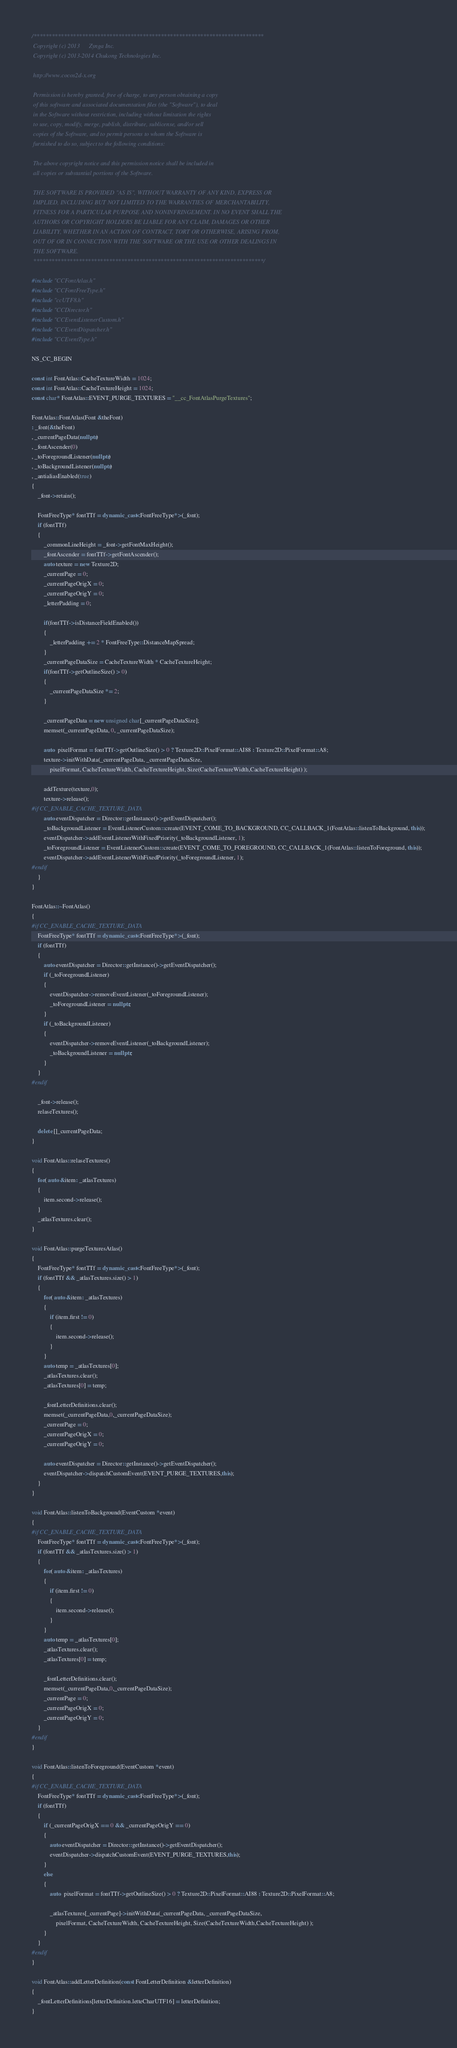Convert code to text. <code><loc_0><loc_0><loc_500><loc_500><_C++_>/****************************************************************************
 Copyright (c) 2013      Zynga Inc.
 Copyright (c) 2013-2014 Chukong Technologies Inc.
 
 http://www.cocos2d-x.org

 Permission is hereby granted, free of charge, to any person obtaining a copy
 of this software and associated documentation files (the "Software"), to deal
 in the Software without restriction, including without limitation the rights
 to use, copy, modify, merge, publish, distribute, sublicense, and/or sell
 copies of the Software, and to permit persons to whom the Software is
 furnished to do so, subject to the following conditions:

 The above copyright notice and this permission notice shall be included in
 all copies or substantial portions of the Software.

 THE SOFTWARE IS PROVIDED "AS IS", WITHOUT WARRANTY OF ANY KIND, EXPRESS OR
 IMPLIED, INCLUDING BUT NOT LIMITED TO THE WARRANTIES OF MERCHANTABILITY,
 FITNESS FOR A PARTICULAR PURPOSE AND NONINFRINGEMENT. IN NO EVENT SHALL THE
 AUTHORS OR COPYRIGHT HOLDERS BE LIABLE FOR ANY CLAIM, DAMAGES OR OTHER
 LIABILITY, WHETHER IN AN ACTION OF CONTRACT, TORT OR OTHERWISE, ARISING FROM,
 OUT OF OR IN CONNECTION WITH THE SOFTWARE OR THE USE OR OTHER DEALINGS IN
 THE SOFTWARE.
 ****************************************************************************/

#include "CCFontAtlas.h"
#include "CCFontFreeType.h"
#include "ccUTF8.h"
#include "CCDirector.h"
#include "CCEventListenerCustom.h"
#include "CCEventDispatcher.h"
#include "CCEventType.h"

NS_CC_BEGIN

const int FontAtlas::CacheTextureWidth = 1024;
const int FontAtlas::CacheTextureHeight = 1024;
const char* FontAtlas::EVENT_PURGE_TEXTURES = "__cc_FontAtlasPurgeTextures";

FontAtlas::FontAtlas(Font &theFont) 
: _font(&theFont)
, _currentPageData(nullptr)
, _fontAscender(0)
, _toForegroundListener(nullptr)
, _toBackgroundListener(nullptr)
, _antialiasEnabled(true)
{
    _font->retain();

    FontFreeType* fontTTf = dynamic_cast<FontFreeType*>(_font);
    if (fontTTf)
    {
        _commonLineHeight = _font->getFontMaxHeight();
        _fontAscender = fontTTf->getFontAscender();
        auto texture = new Texture2D;
        _currentPage = 0;
        _currentPageOrigX = 0;
        _currentPageOrigY = 0;
        _letterPadding = 0;

        if(fontTTf->isDistanceFieldEnabled())
        {
            _letterPadding += 2 * FontFreeType::DistanceMapSpread;    
        }
        _currentPageDataSize = CacheTextureWidth * CacheTextureHeight;
        if(fontTTf->getOutlineSize() > 0)
        {
            _currentPageDataSize *= 2;
        }    

        _currentPageData = new unsigned char[_currentPageDataSize];
        memset(_currentPageData, 0, _currentPageDataSize);

        auto  pixelFormat = fontTTf->getOutlineSize() > 0 ? Texture2D::PixelFormat::AI88 : Texture2D::PixelFormat::A8; 
        texture->initWithData(_currentPageData, _currentPageDataSize, 
            pixelFormat, CacheTextureWidth, CacheTextureHeight, Size(CacheTextureWidth,CacheTextureHeight) );

        addTexture(texture,0);
        texture->release();
#if CC_ENABLE_CACHE_TEXTURE_DATA
        auto eventDispatcher = Director::getInstance()->getEventDispatcher();
        _toBackgroundListener = EventListenerCustom::create(EVENT_COME_TO_BACKGROUND, CC_CALLBACK_1(FontAtlas::listenToBackground, this));
        eventDispatcher->addEventListenerWithFixedPriority(_toBackgroundListener, 1);
        _toForegroundListener = EventListenerCustom::create(EVENT_COME_TO_FOREGROUND, CC_CALLBACK_1(FontAtlas::listenToForeground, this));
        eventDispatcher->addEventListenerWithFixedPriority(_toForegroundListener, 1);
#endif
    }
}

FontAtlas::~FontAtlas()
{
#if CC_ENABLE_CACHE_TEXTURE_DATA
    FontFreeType* fontTTf = dynamic_cast<FontFreeType*>(_font);
    if (fontTTf)
    {
        auto eventDispatcher = Director::getInstance()->getEventDispatcher();
        if (_toForegroundListener)
        {
            eventDispatcher->removeEventListener(_toForegroundListener);
            _toForegroundListener = nullptr;
        }
        if (_toBackgroundListener)
        {
            eventDispatcher->removeEventListener(_toBackgroundListener);
            _toBackgroundListener = nullptr;
        }
    }
#endif

    _font->release();
    relaseTextures();

    delete []_currentPageData;
}

void FontAtlas::relaseTextures()
{
    for( auto &item: _atlasTextures)
    {
        item.second->release();
    }
    _atlasTextures.clear();
}

void FontAtlas::purgeTexturesAtlas()
{
    FontFreeType* fontTTf = dynamic_cast<FontFreeType*>(_font);
    if (fontTTf && _atlasTextures.size() > 1)
    {
        for( auto &item: _atlasTextures)
        {
            if (item.first != 0)
            {
                item.second->release();
            }
        }
        auto temp = _atlasTextures[0];
        _atlasTextures.clear();
        _atlasTextures[0] = temp;

        _fontLetterDefinitions.clear();
        memset(_currentPageData,0,_currentPageDataSize);
        _currentPage = 0;
        _currentPageOrigX = 0;
        _currentPageOrigY = 0;

        auto eventDispatcher = Director::getInstance()->getEventDispatcher();
        eventDispatcher->dispatchCustomEvent(EVENT_PURGE_TEXTURES,this);
    }
}

void FontAtlas::listenToBackground(EventCustom *event)
{
#if CC_ENABLE_CACHE_TEXTURE_DATA
    FontFreeType* fontTTf = dynamic_cast<FontFreeType*>(_font);
    if (fontTTf && _atlasTextures.size() > 1)
    {
        for( auto &item: _atlasTextures)
        {
            if (item.first != 0)
            {
                item.second->release();
            }
        }
        auto temp = _atlasTextures[0];
        _atlasTextures.clear();
        _atlasTextures[0] = temp;

        _fontLetterDefinitions.clear();
        memset(_currentPageData,0,_currentPageDataSize);
        _currentPage = 0;
        _currentPageOrigX = 0;
        _currentPageOrigY = 0;
    }
#endif
}

void FontAtlas::listenToForeground(EventCustom *event)
{
#if CC_ENABLE_CACHE_TEXTURE_DATA
    FontFreeType* fontTTf = dynamic_cast<FontFreeType*>(_font);
    if (fontTTf)
    {
        if (_currentPageOrigX == 0 && _currentPageOrigY == 0)
        {
            auto eventDispatcher = Director::getInstance()->getEventDispatcher();
            eventDispatcher->dispatchCustomEvent(EVENT_PURGE_TEXTURES,this);
        }
        else
        {
            auto  pixelFormat = fontTTf->getOutlineSize() > 0 ? Texture2D::PixelFormat::AI88 : Texture2D::PixelFormat::A8;

            _atlasTextures[_currentPage]->initWithData(_currentPageData, _currentPageDataSize, 
                pixelFormat, CacheTextureWidth, CacheTextureHeight, Size(CacheTextureWidth,CacheTextureHeight) );
        }
    }
#endif
}

void FontAtlas::addLetterDefinition(const FontLetterDefinition &letterDefinition)
{
    _fontLetterDefinitions[letterDefinition.letteCharUTF16] = letterDefinition;
}
</code> 